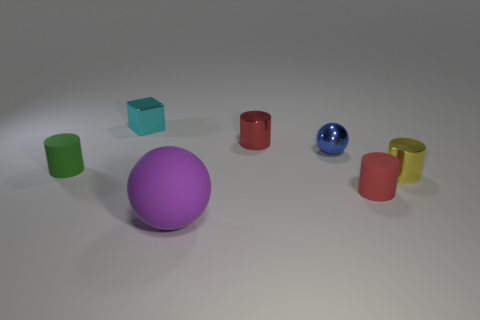How many objects are red shiny things or tiny matte cylinders that are to the left of the big sphere?
Keep it short and to the point. 2. What material is the small thing that is on the left side of the small red metallic cylinder and on the right side of the green thing?
Your response must be concise. Metal. What is the ball that is behind the big purple object made of?
Give a very brief answer. Metal. There is a sphere that is made of the same material as the cyan object; what is its color?
Ensure brevity in your answer.  Blue. There is a tiny cyan object; does it have the same shape as the red object behind the green cylinder?
Offer a very short reply. No. Are there any large rubber objects behind the tiny cyan cube?
Provide a succinct answer. No. There is a yellow metal object; is its size the same as the cylinder that is behind the tiny green object?
Your answer should be very brief. Yes. Are there any large matte things that have the same color as the metal cube?
Offer a terse response. No. Are there any small red shiny objects that have the same shape as the yellow shiny thing?
Keep it short and to the point. Yes. What shape is the object that is to the left of the red metallic cylinder and right of the block?
Your answer should be very brief. Sphere. 